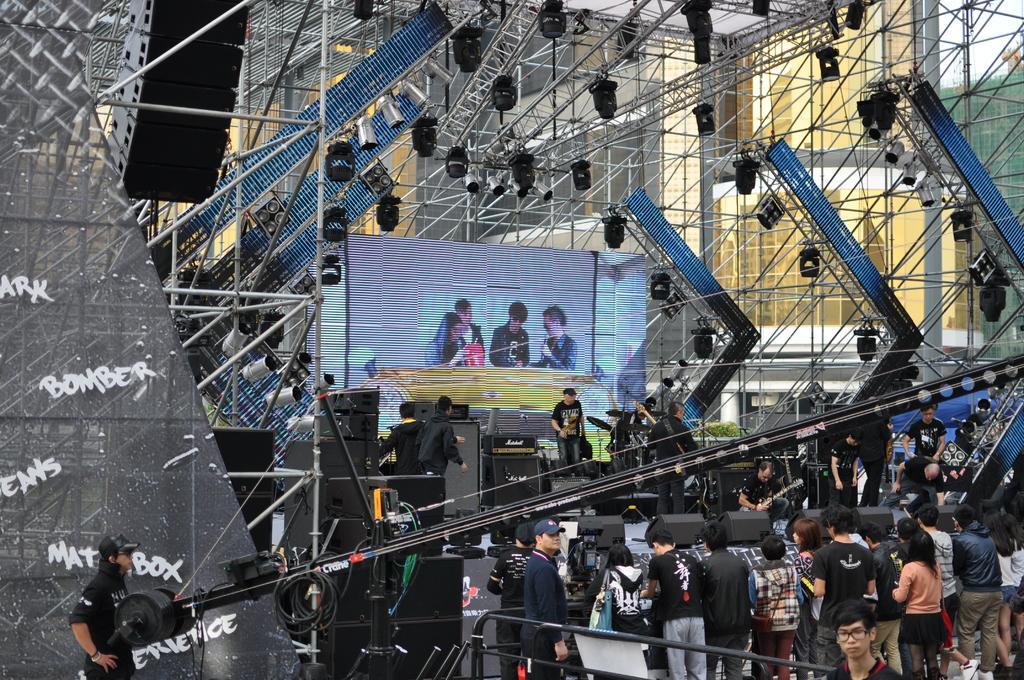How would you summarize this image in a sentence or two? In this picture we can see some people standing in the front, in the background there is a stage, we can see some people standing on the stage, we can also see a screen, speakers. There are some lights and metal rods at the top of the picture, there is a building in the background, we can see four persons on the screen, there are some wires in the front. 